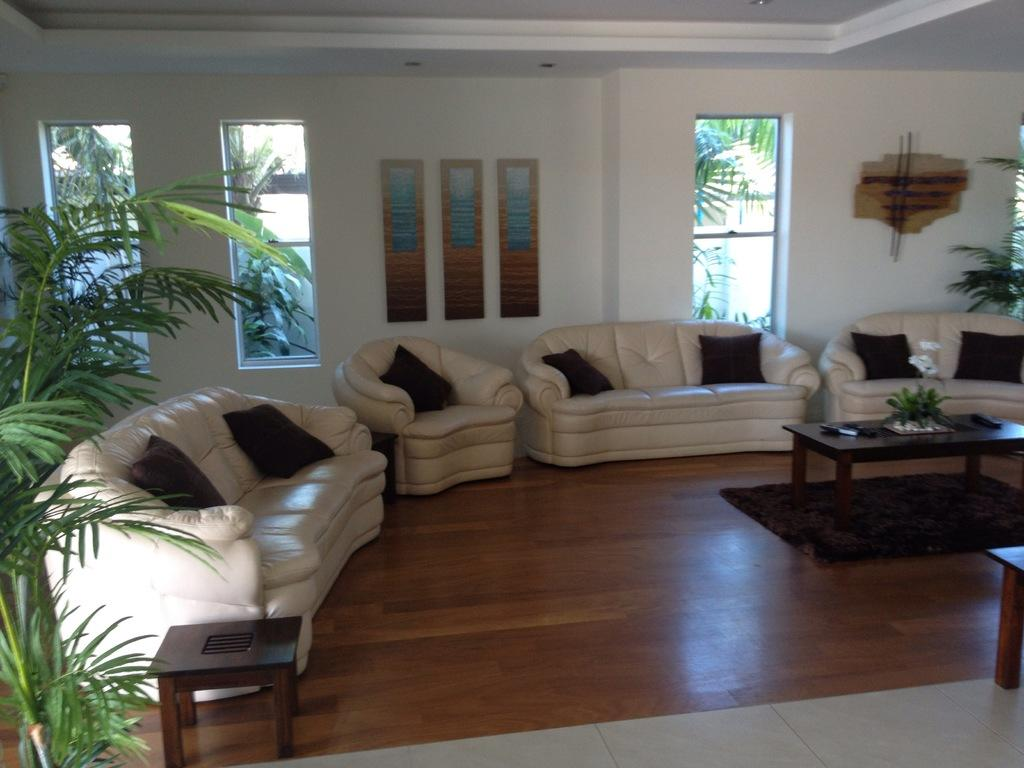What is the color of the wall in the image? The wall in the image is white. What can be seen on the wall in the image? There is a window visible on the wall in the image. What is visible outside the window in the image? Trees are visible outside the window in the image. What type of furniture is present in the image? There are sofas and a table in the image. What type of accessory is present on the sofas in the image? There are pillows on the sofas in the image. Where is the crown placed in the image? There is no crown present in the image. What trick can be performed with the table in the image? There is no trick associated with the table in the image; it is a regular table. 